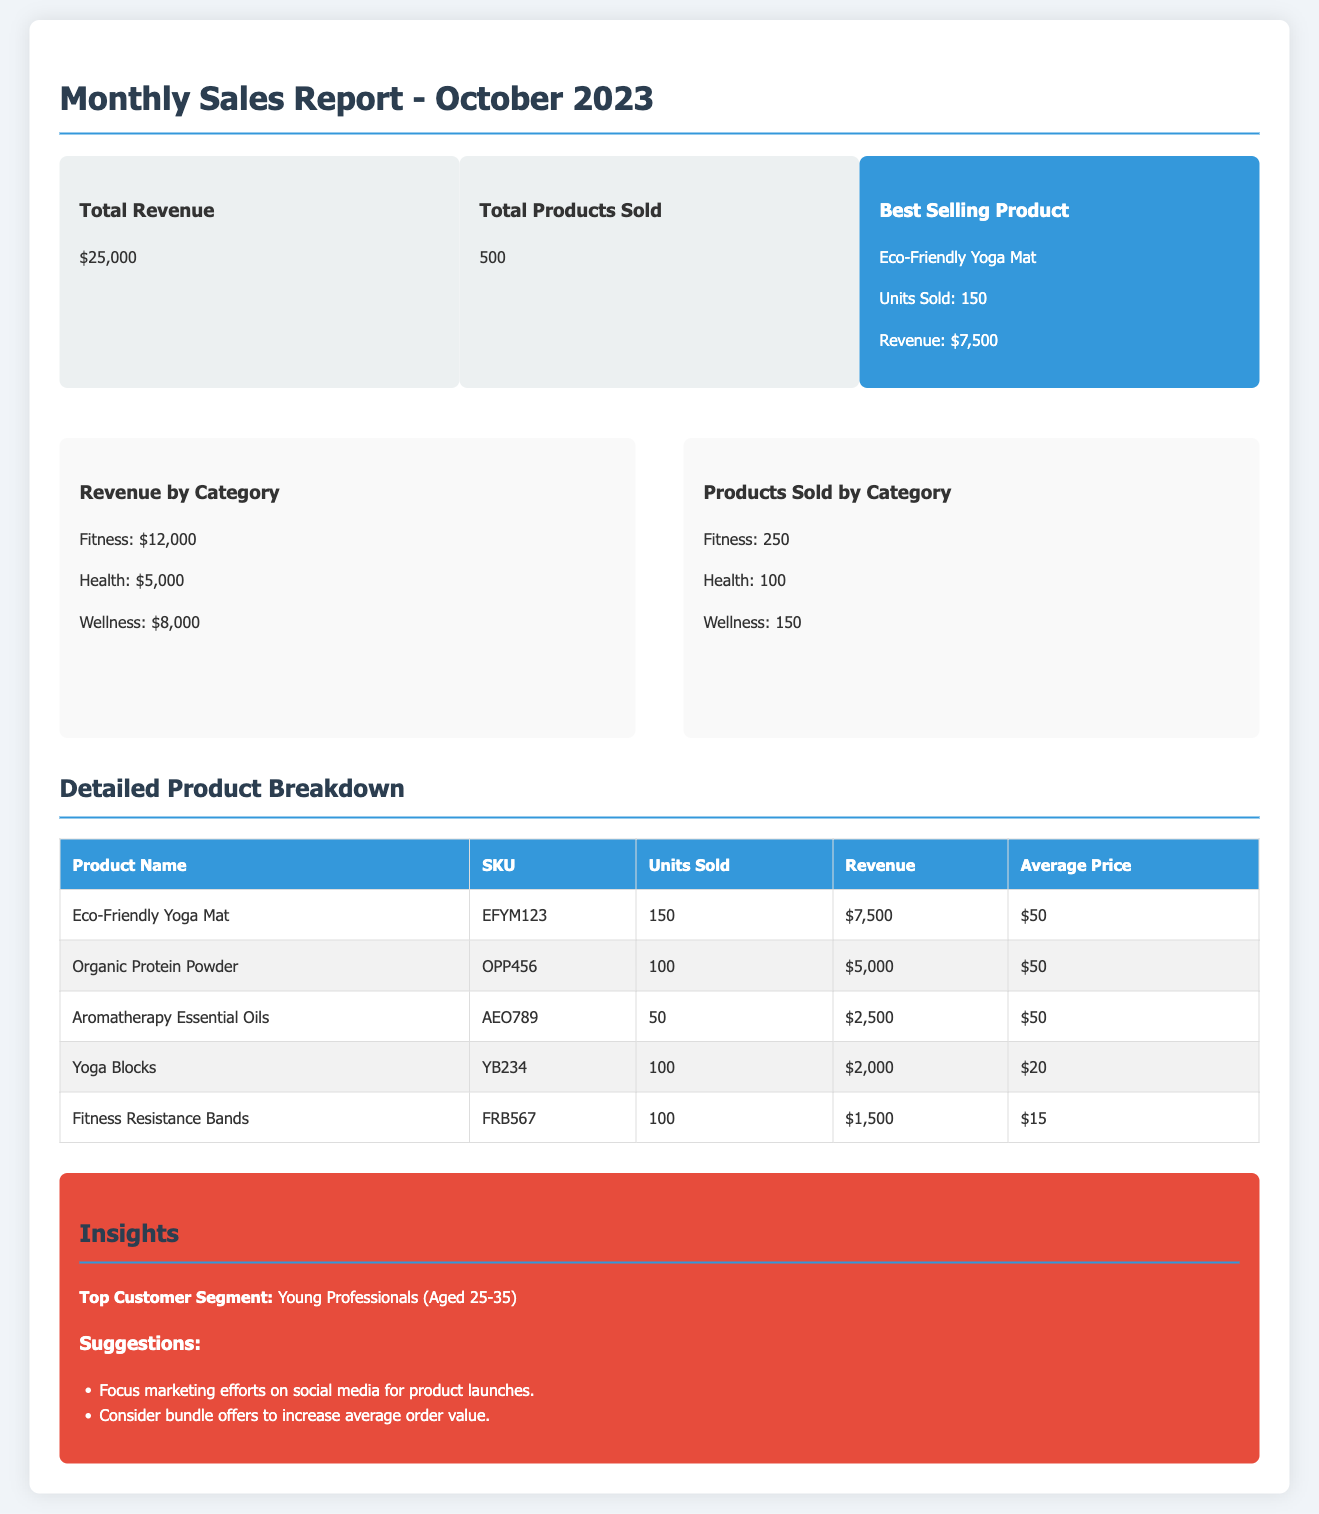What was the total revenue for October 2023? The total revenue is stated in the overview section of the document, amounting to $25,000.
Answer: $25,000 How many units of the Eco-Friendly Yoga Mat were sold? The number of units sold for the Eco-Friendly Yoga Mat is mentioned in the overview as 150 units.
Answer: 150 What is the revenue generated from the Organic Protein Powder? The revenue for the Organic Protein Powder is provided in the detailed product breakdown, which shows $5,000.
Answer: $5,000 Which product was the best seller? The best selling product is highlighted in the overview section as the Eco-Friendly Yoga Mat.
Answer: Eco-Friendly Yoga Mat What is the average price of the Fitness Resistance Bands? The average price for the Fitness Resistance Bands is listed in the detailed product breakdown as $15.
Answer: $15 How many products were sold in the Health category? The number of products sold in the Health category is shown in the "Products Sold by Category" chart as 100.
Answer: 100 What demographic is identified as the top customer segment? The insights section states that the top customer segment is Young Professionals (Aged 25-35).
Answer: Young Professionals (Aged 25-35) What marketing strategy is suggested for product launches? The insights section recommends focusing marketing efforts on social media for product launches.
Answer: Social media What revenue did the Wellness category generate? The revenue generated from the Wellness category is specified in the revenue chart as $8,000.
Answer: $8,000 